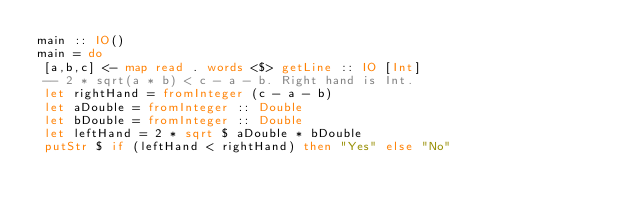<code> <loc_0><loc_0><loc_500><loc_500><_Haskell_>main :: IO()
main = do
 [a,b,c] <- map read . words <$> getLine :: IO [Int]
 -- 2 * sqrt(a * b) < c - a - b. Right hand is Int.
 let rightHand = fromInteger (c - a - b)
 let aDouble = fromInteger :: Double
 let bDouble = fromInteger :: Double 
 let leftHand = 2 * sqrt $ aDouble * bDouble
 putStr $ if (leftHand < rightHand) then "Yes" else "No"
</code> 